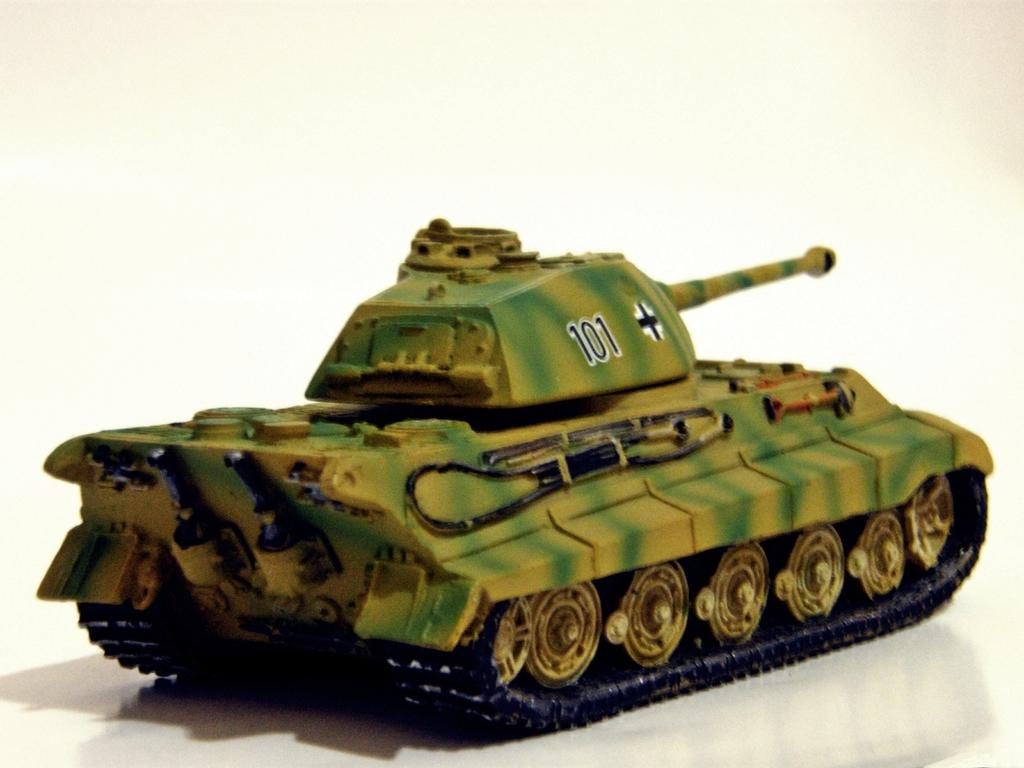What is the main subject in the foreground of the image? There is a toy tank in the foreground of the image. What is the toy tank placed on in the image? The toy tank is on a white surface. What color is the background of the image? The background of the image is white. What type of quartz can be seen in the image? There is no quartz present in the image. How much dust can be seen on the toy tank in the image? There is no dust visible on the toy tank in the image. 